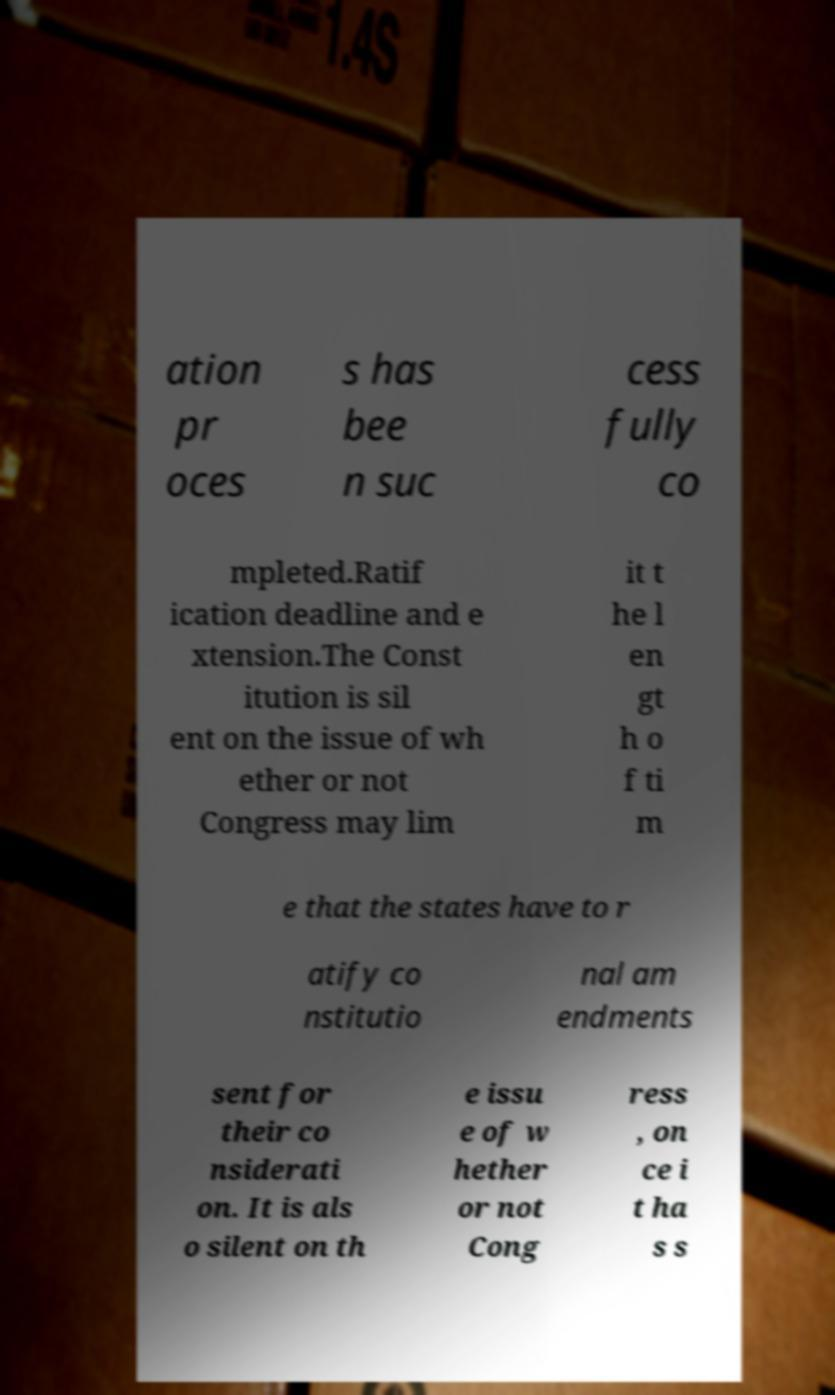Can you read and provide the text displayed in the image?This photo seems to have some interesting text. Can you extract and type it out for me? ation pr oces s has bee n suc cess fully co mpleted.Ratif ication deadline and e xtension.The Const itution is sil ent on the issue of wh ether or not Congress may lim it t he l en gt h o f ti m e that the states have to r atify co nstitutio nal am endments sent for their co nsiderati on. It is als o silent on th e issu e of w hether or not Cong ress , on ce i t ha s s 